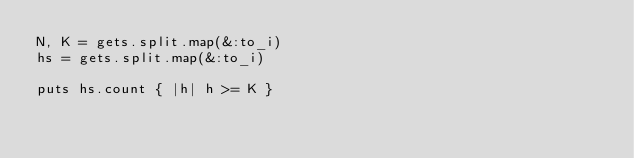<code> <loc_0><loc_0><loc_500><loc_500><_Ruby_>N, K = gets.split.map(&:to_i)
hs = gets.split.map(&:to_i)

puts hs.count { |h| h >= K }
</code> 